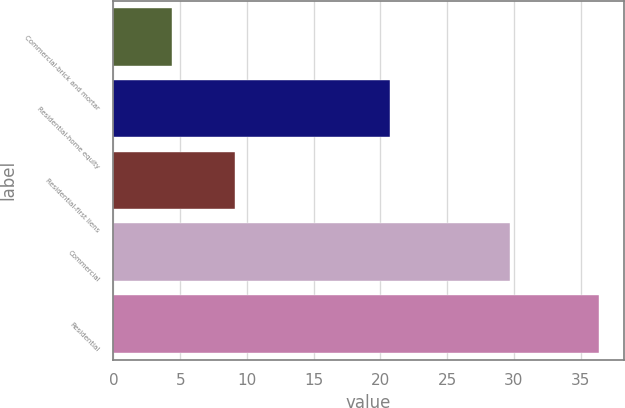Convert chart to OTSL. <chart><loc_0><loc_0><loc_500><loc_500><bar_chart><fcel>Commercial-brick and mortar<fcel>Residential-home equity<fcel>Residential-first liens<fcel>Commercial<fcel>Residential<nl><fcel>4.4<fcel>20.7<fcel>9.1<fcel>29.7<fcel>36.4<nl></chart> 